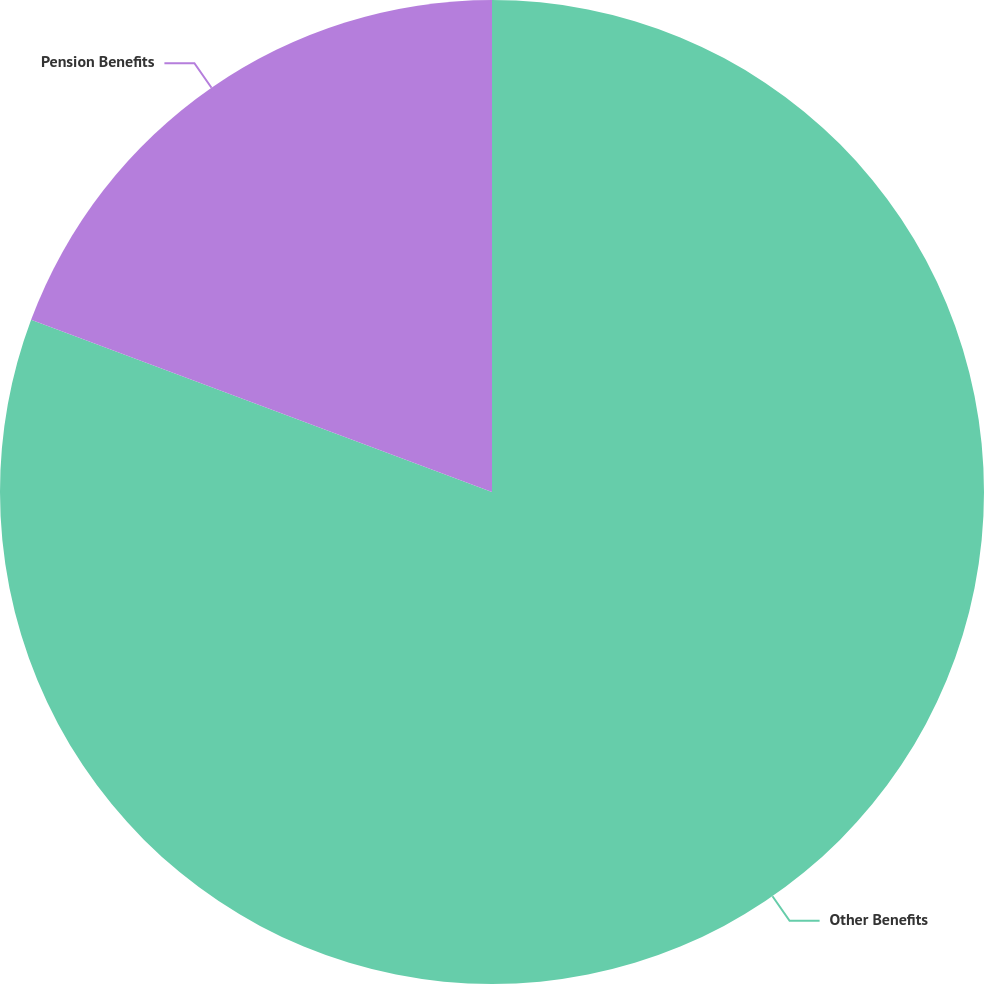Convert chart. <chart><loc_0><loc_0><loc_500><loc_500><pie_chart><fcel>Other Benefits<fcel>Pension Benefits<nl><fcel>80.69%<fcel>19.31%<nl></chart> 